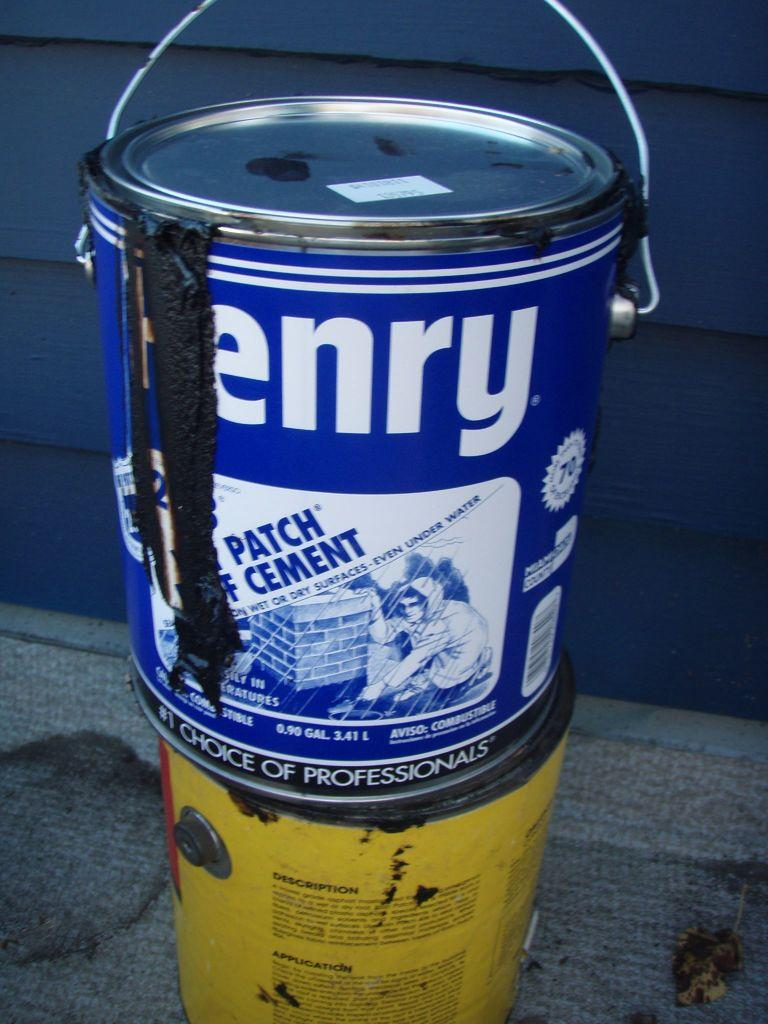<image>
Summarize the visual content of the image. Blue Henry paint can on top of another yellow can. 